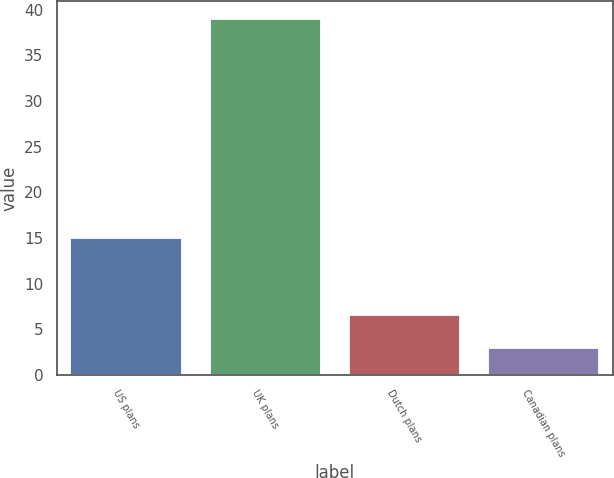Convert chart. <chart><loc_0><loc_0><loc_500><loc_500><bar_chart><fcel>US plans<fcel>UK plans<fcel>Dutch plans<fcel>Canadian plans<nl><fcel>15<fcel>39<fcel>6.6<fcel>3<nl></chart> 